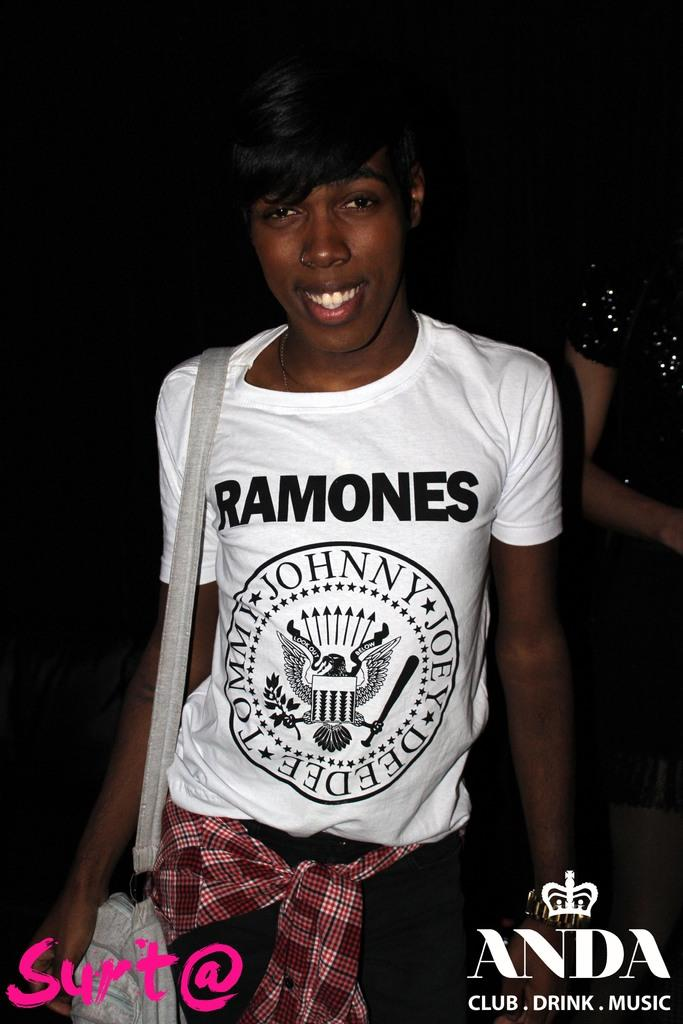Who or what is the main subject in the image? There is a person in the image. What can be observed about the background in the image? The person is on a dark background. What is the person wearing in the image? The person is wearing clothes. What is the person carrying in the image? The person is carrying a bag. What type of bit is the person offering to the cattle in the image? There is no bit or cattle present in the image; it only features a person wearing clothes and carrying a bag. 